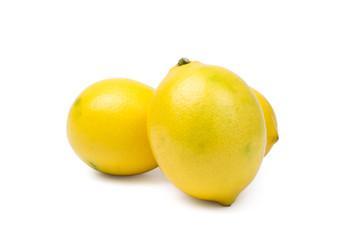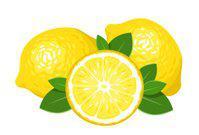The first image is the image on the left, the second image is the image on the right. Examine the images to the left and right. Is the description "There is one image with exactly five green leaves." accurate? Answer yes or no. No. The first image is the image on the left, the second image is the image on the right. Examine the images to the left and right. Is the description "in the left image the lemons are left whole" accurate? Answer yes or no. Yes. 